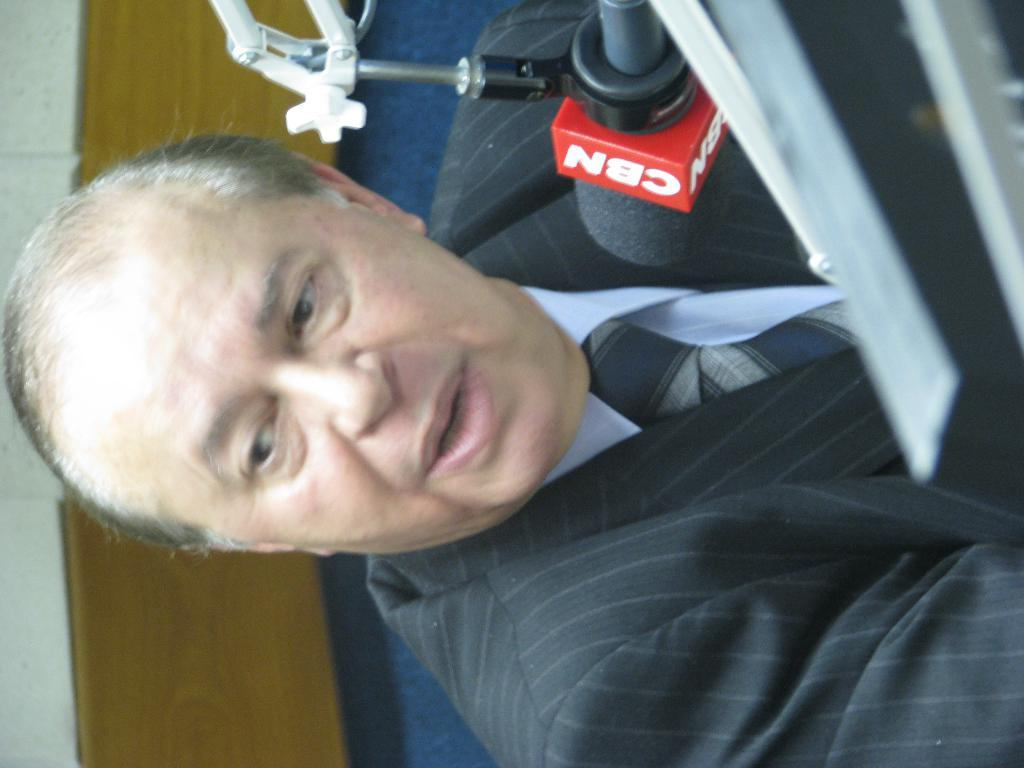Who or what is the main subject in the image? There is a person in the image. What object is in front of the person? There is a mic with text on it in front of the person. What can be seen behind the person? There is a wall visible in the image. What is the taste of the person in the image? The taste of the person cannot be determined from the image, as taste is a sensory experience and not a visual characteristic. 